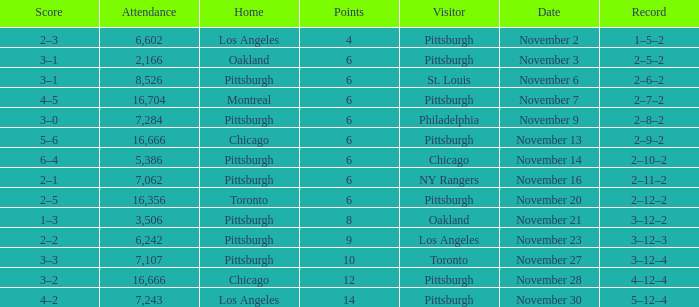What is the lowest amount of points of the game with toronto as the home team? 6.0. 